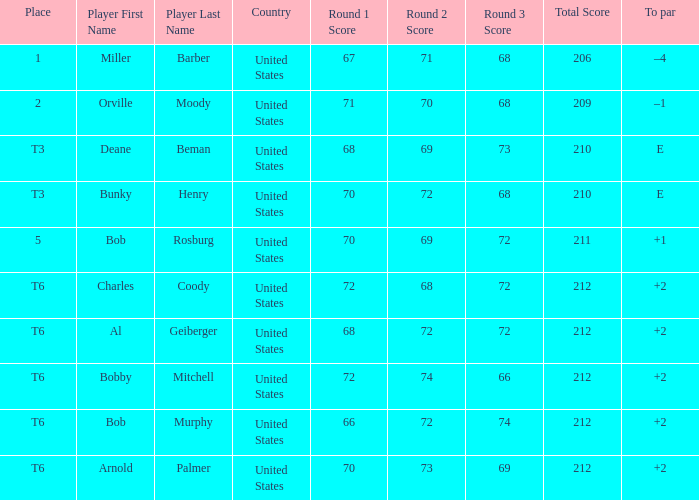Who is the player with a t6 place and a 72-68-72=212 score? Charles Coody. 